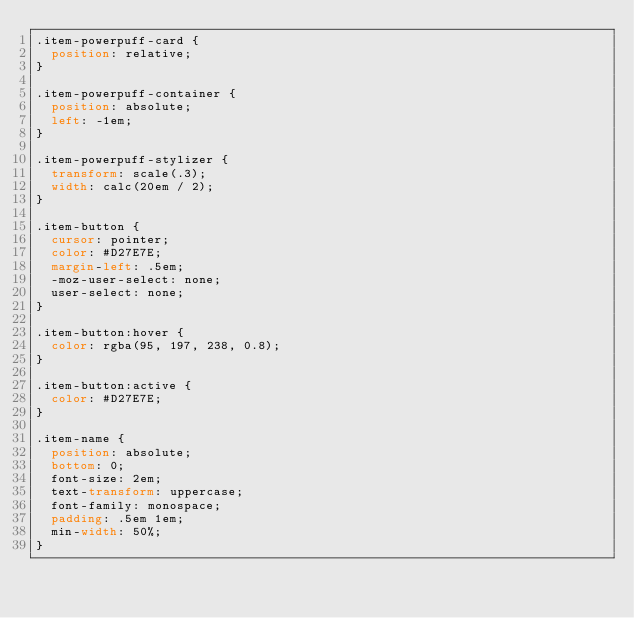Convert code to text. <code><loc_0><loc_0><loc_500><loc_500><_CSS_>.item-powerpuff-card {
  position: relative;
}

.item-powerpuff-container {
  position: absolute;
  left: -1em;
}

.item-powerpuff-stylizer {
  transform: scale(.3);
  width: calc(20em / 2);
}

.item-button {
  cursor: pointer;
  color: #D27E7E;
  margin-left: .5em;
  -moz-user-select: none;
  user-select: none;
}

.item-button:hover {
  color: rgba(95, 197, 238, 0.8);
}

.item-button:active {
  color: #D27E7E;
}

.item-name {
  position: absolute;
  bottom: 0;
  font-size: 2em;
  text-transform: uppercase;
  font-family: monospace;
  padding: .5em 1em;
  min-width: 50%;
}


</code> 